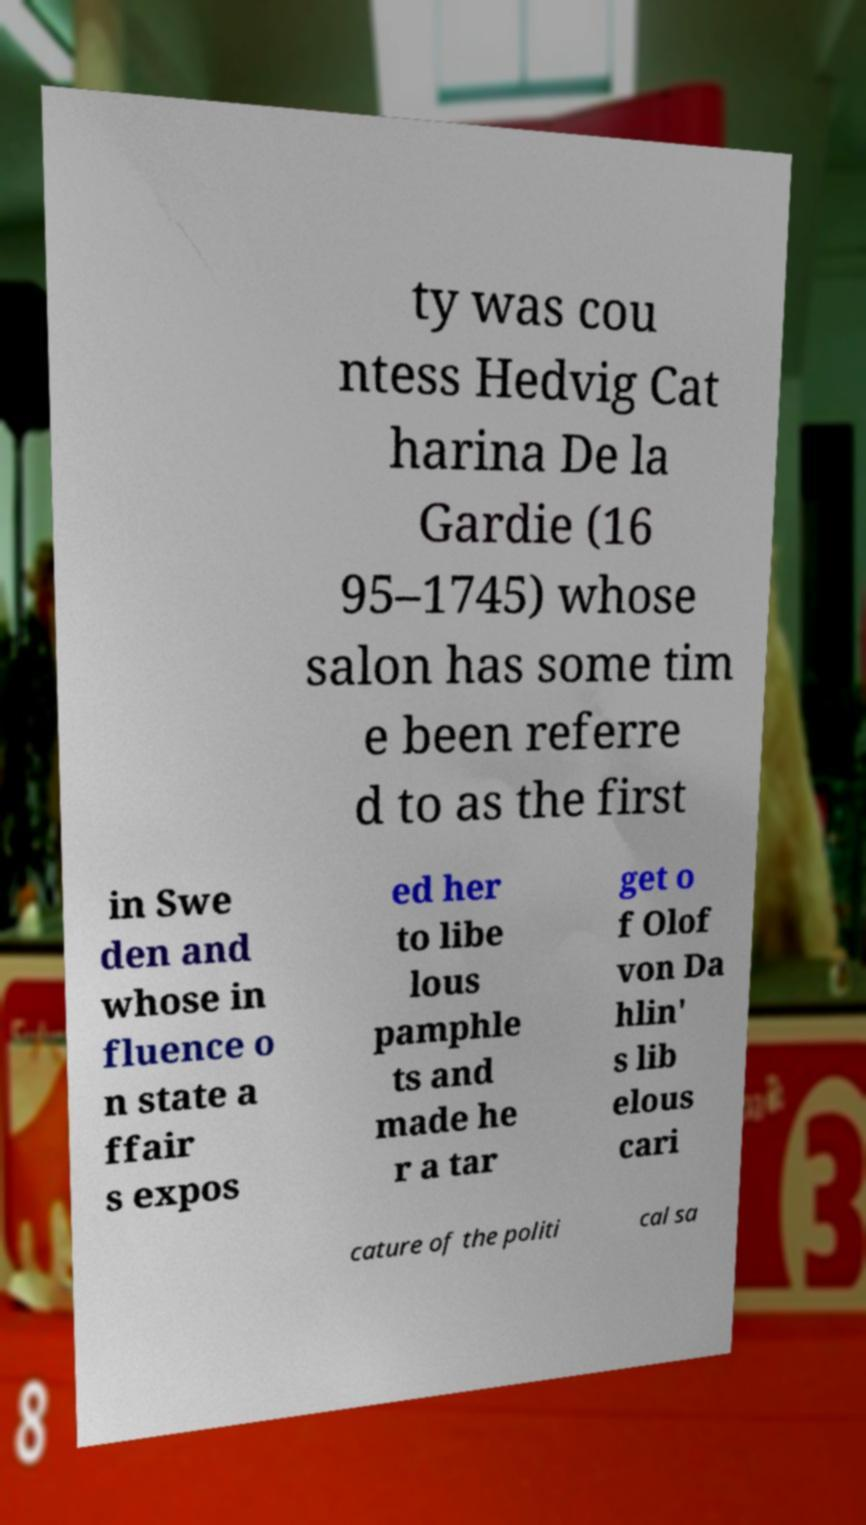I need the written content from this picture converted into text. Can you do that? ty was cou ntess Hedvig Cat harina De la Gardie (16 95–1745) whose salon has some tim e been referre d to as the first in Swe den and whose in fluence o n state a ffair s expos ed her to libe lous pamphle ts and made he r a tar get o f Olof von Da hlin' s lib elous cari cature of the politi cal sa 